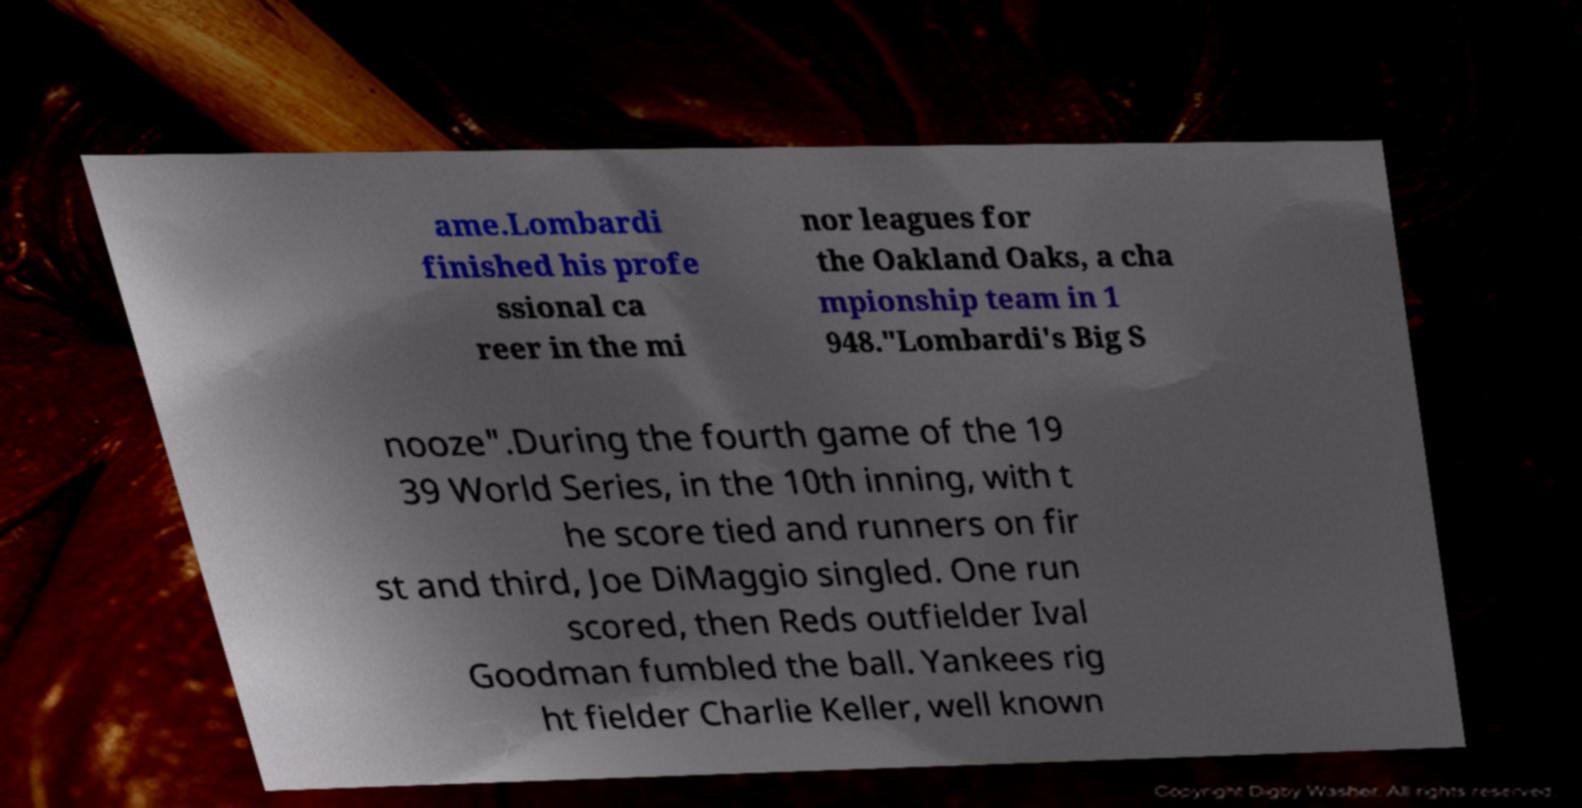Please identify and transcribe the text found in this image. ame.Lombardi finished his profe ssional ca reer in the mi nor leagues for the Oakland Oaks, a cha mpionship team in 1 948."Lombardi's Big S nooze".During the fourth game of the 19 39 World Series, in the 10th inning, with t he score tied and runners on fir st and third, Joe DiMaggio singled. One run scored, then Reds outfielder Ival Goodman fumbled the ball. Yankees rig ht fielder Charlie Keller, well known 